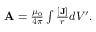Convert formula to latex. <formula><loc_0><loc_0><loc_500><loc_500>\begin{array} { r } { { \mathbf A } = \frac { \mu _ { 0 } } { 4 \pi } \int { \frac { [ { \mathbf J } ] } { r } } d V ^ { \prime } . } \end{array}</formula> 